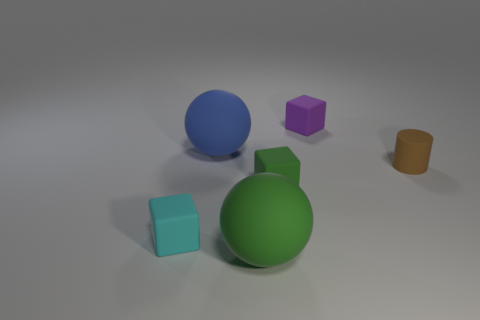Subtract all tiny cyan blocks. How many blocks are left? 2 Add 4 cyan rubber objects. How many objects exist? 10 Subtract all green blocks. How many blocks are left? 2 Subtract all balls. How many objects are left? 4 Subtract all green cylinders. How many green balls are left? 1 Subtract all tiny green blocks. Subtract all brown cylinders. How many objects are left? 4 Add 4 tiny cyan rubber blocks. How many tiny cyan rubber blocks are left? 5 Add 3 blue matte balls. How many blue matte balls exist? 4 Subtract 0 purple cylinders. How many objects are left? 6 Subtract all green cylinders. Subtract all cyan cubes. How many cylinders are left? 1 